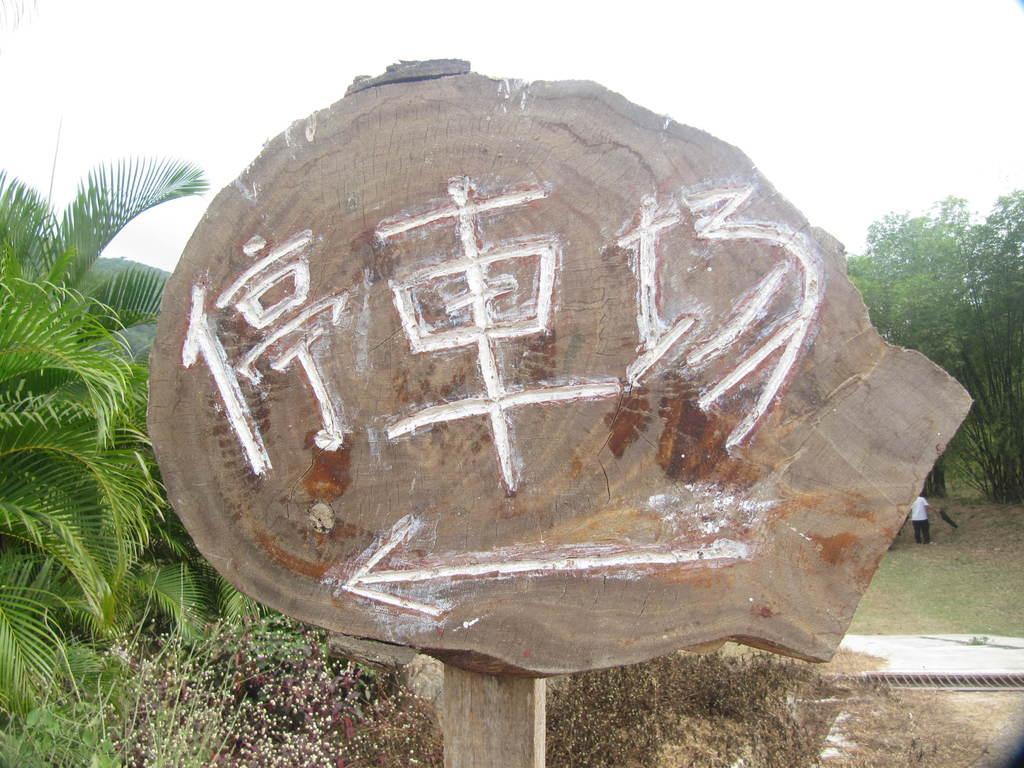How would you summarize this image in a sentence or two? In this image I can see the wooden board and something is carved on it. In the background I can see the planets, person with white and black color dress, trees and the sky. 